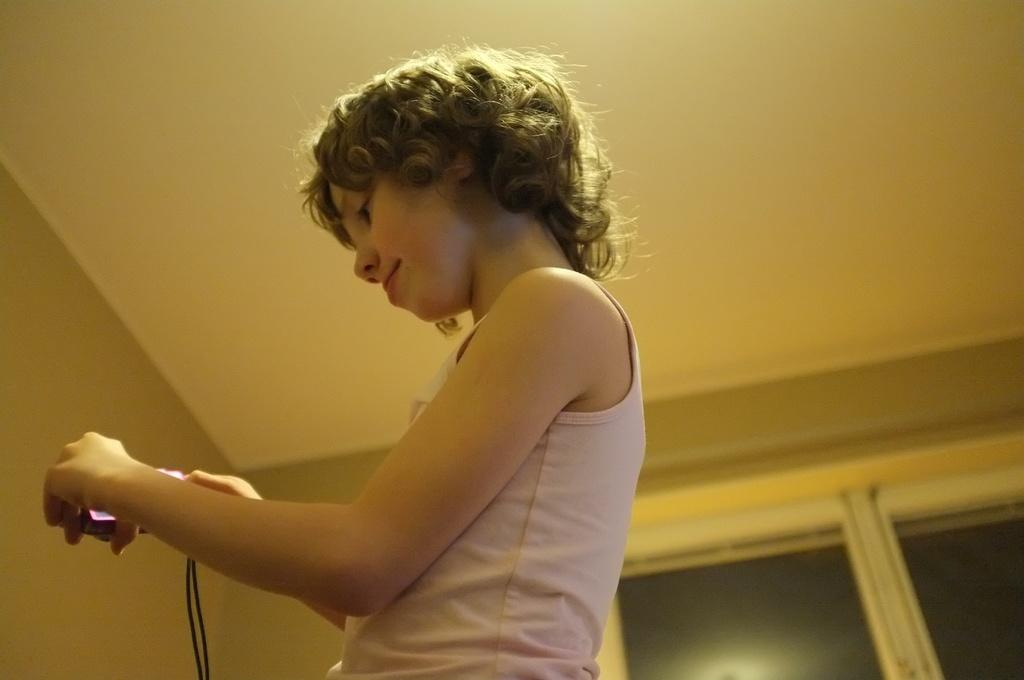What is the main subject of the image? There is a small girl in the image. What is the girl wearing? The girl is wearing a white top. What is the girl holding in her hand? The girl is holding a phone in her hand. What is the girl doing with the phone? The girl is looking at the phone. What can be seen in the background of the image? There is a white glass window and brown walls in the background. What type of dress is the girl's father wearing in the image? There is no father present in the image, and therefore no dress to describe. Who is the expert in the image? There is no expert present in the image; it features a small girl looking at a phone. 